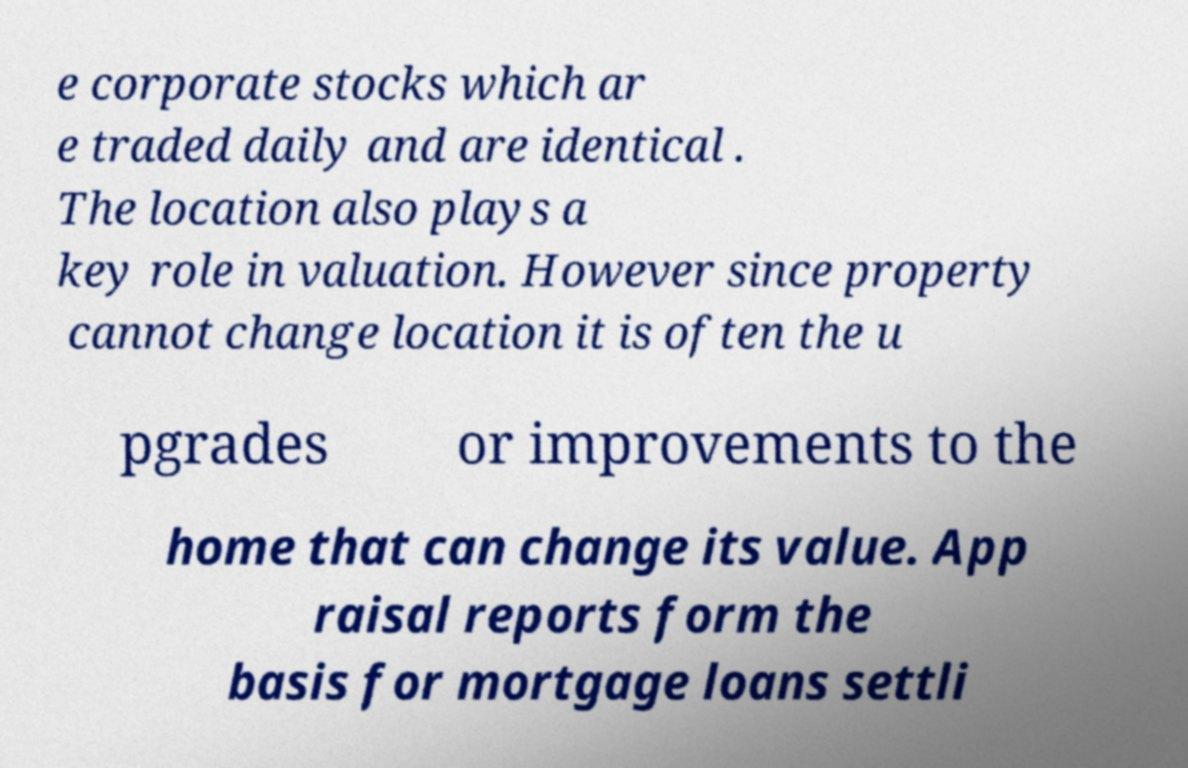Can you read and provide the text displayed in the image?This photo seems to have some interesting text. Can you extract and type it out for me? e corporate stocks which ar e traded daily and are identical . The location also plays a key role in valuation. However since property cannot change location it is often the u pgrades or improvements to the home that can change its value. App raisal reports form the basis for mortgage loans settli 